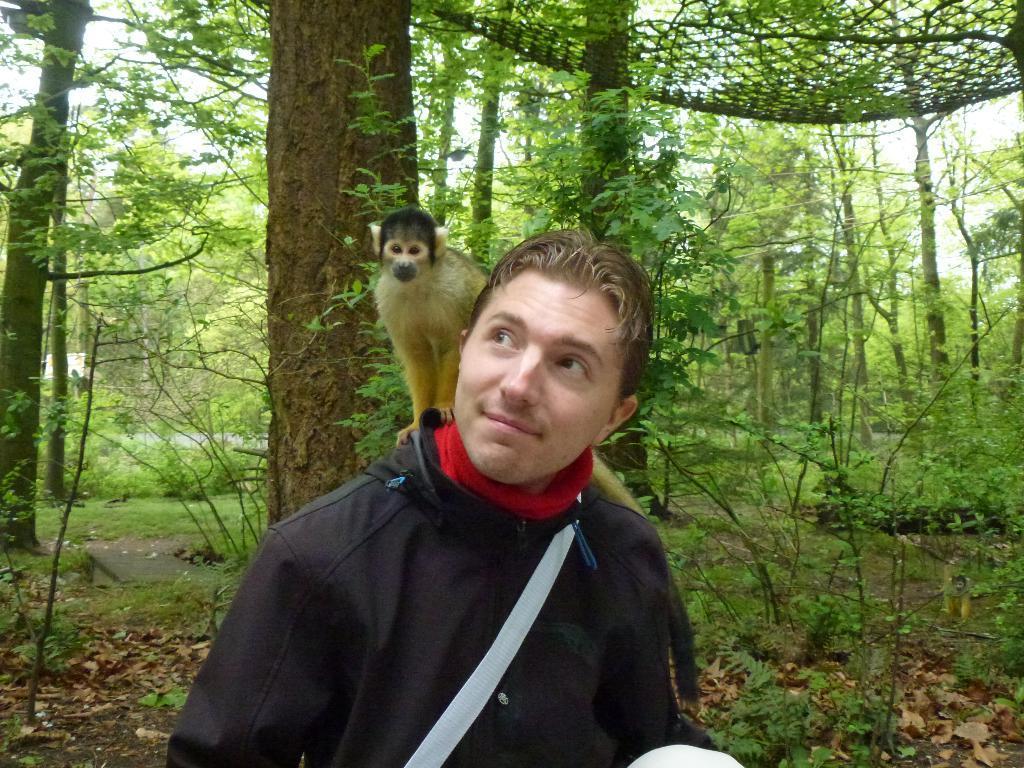Can you describe this image briefly? In this image In the middle there is a man he wear black jacket on him there is a monkey. In the background there are many trees and plants. 